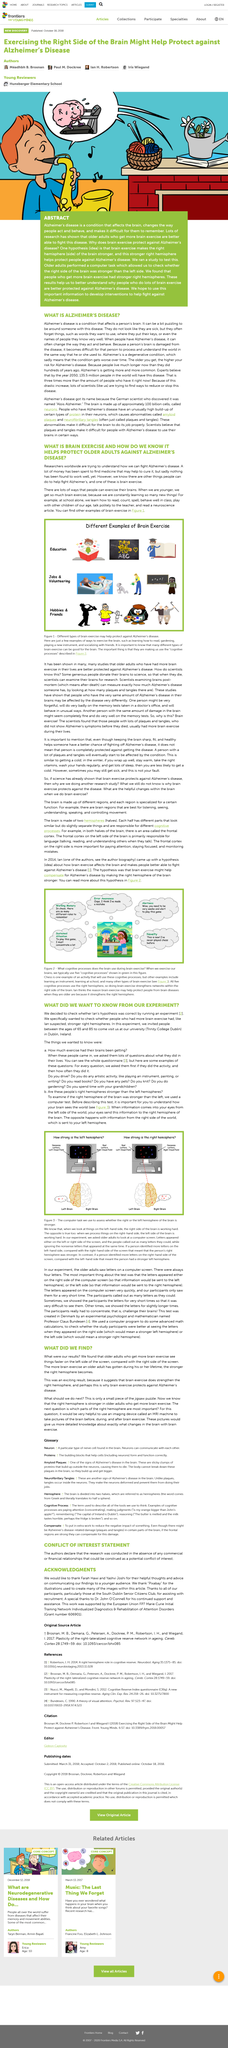List a handful of essential elements in this visual. This article is about acknowledgment. The first four things that we learn from school are reading, counting, spelling, and behaving well in class. The result indicates that brain exercise strengthens the right hemisphere. We have established that engaging in brain exercise is effective in protecting older adults from the negative effects of brain exercise. The grant number is 606901. 